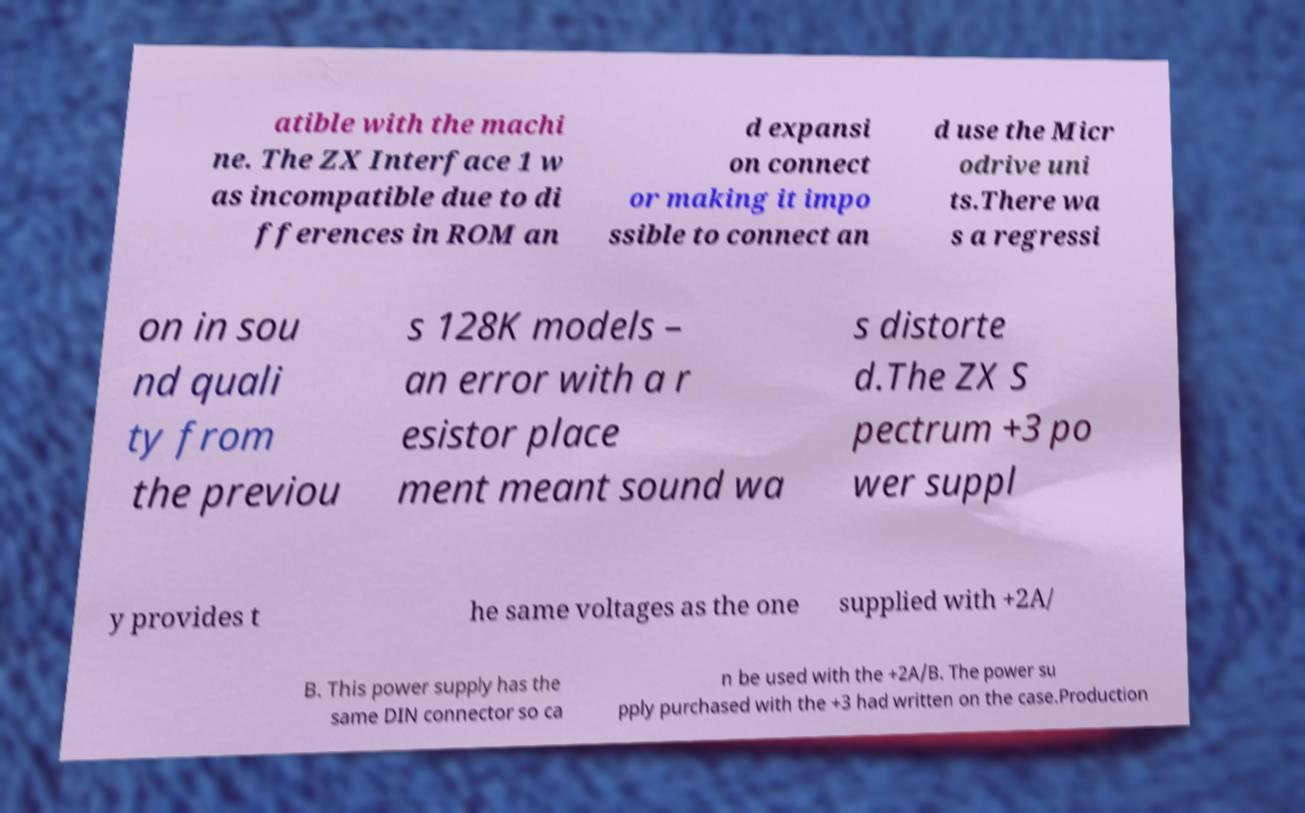Can you read and provide the text displayed in the image?This photo seems to have some interesting text. Can you extract and type it out for me? atible with the machi ne. The ZX Interface 1 w as incompatible due to di fferences in ROM an d expansi on connect or making it impo ssible to connect an d use the Micr odrive uni ts.There wa s a regressi on in sou nd quali ty from the previou s 128K models – an error with a r esistor place ment meant sound wa s distorte d.The ZX S pectrum +3 po wer suppl y provides t he same voltages as the one supplied with +2A/ B. This power supply has the same DIN connector so ca n be used with the +2A/B. The power su pply purchased with the +3 had written on the case.Production 